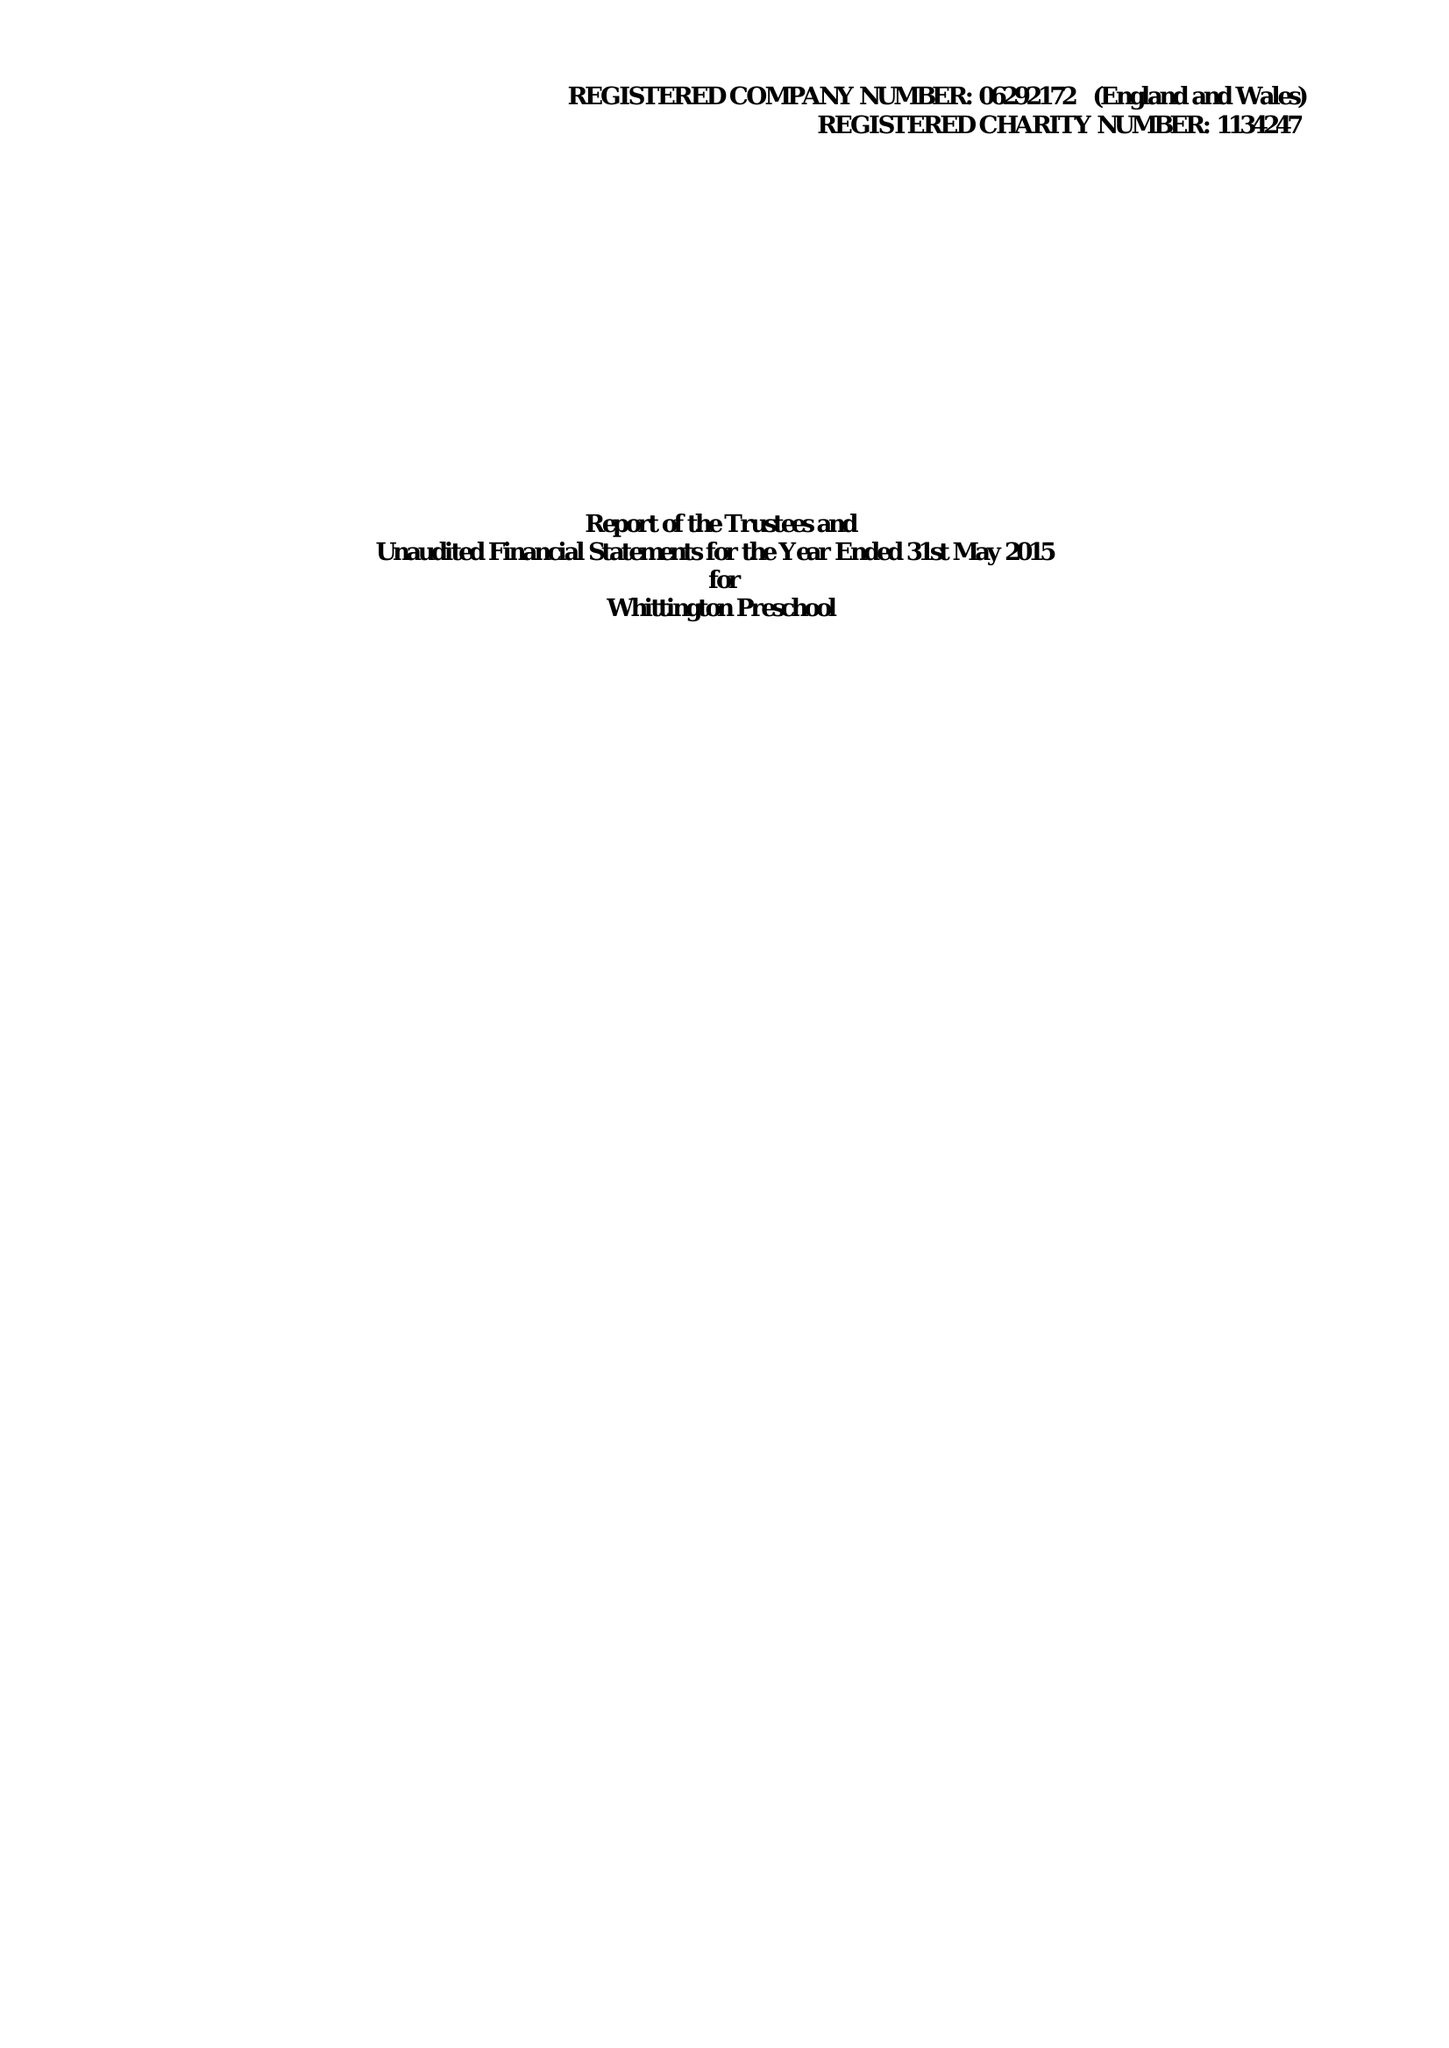What is the value for the report_date?
Answer the question using a single word or phrase. 2015-05-31 